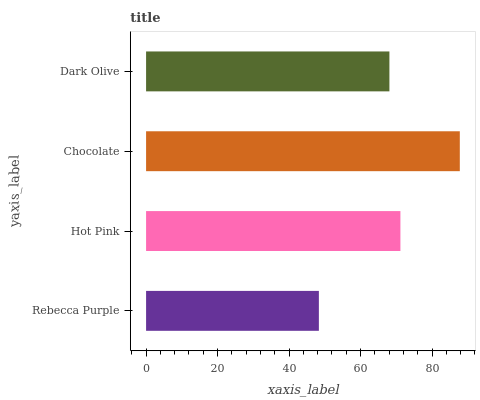Is Rebecca Purple the minimum?
Answer yes or no. Yes. Is Chocolate the maximum?
Answer yes or no. Yes. Is Hot Pink the minimum?
Answer yes or no. No. Is Hot Pink the maximum?
Answer yes or no. No. Is Hot Pink greater than Rebecca Purple?
Answer yes or no. Yes. Is Rebecca Purple less than Hot Pink?
Answer yes or no. Yes. Is Rebecca Purple greater than Hot Pink?
Answer yes or no. No. Is Hot Pink less than Rebecca Purple?
Answer yes or no. No. Is Hot Pink the high median?
Answer yes or no. Yes. Is Dark Olive the low median?
Answer yes or no. Yes. Is Dark Olive the high median?
Answer yes or no. No. Is Chocolate the low median?
Answer yes or no. No. 